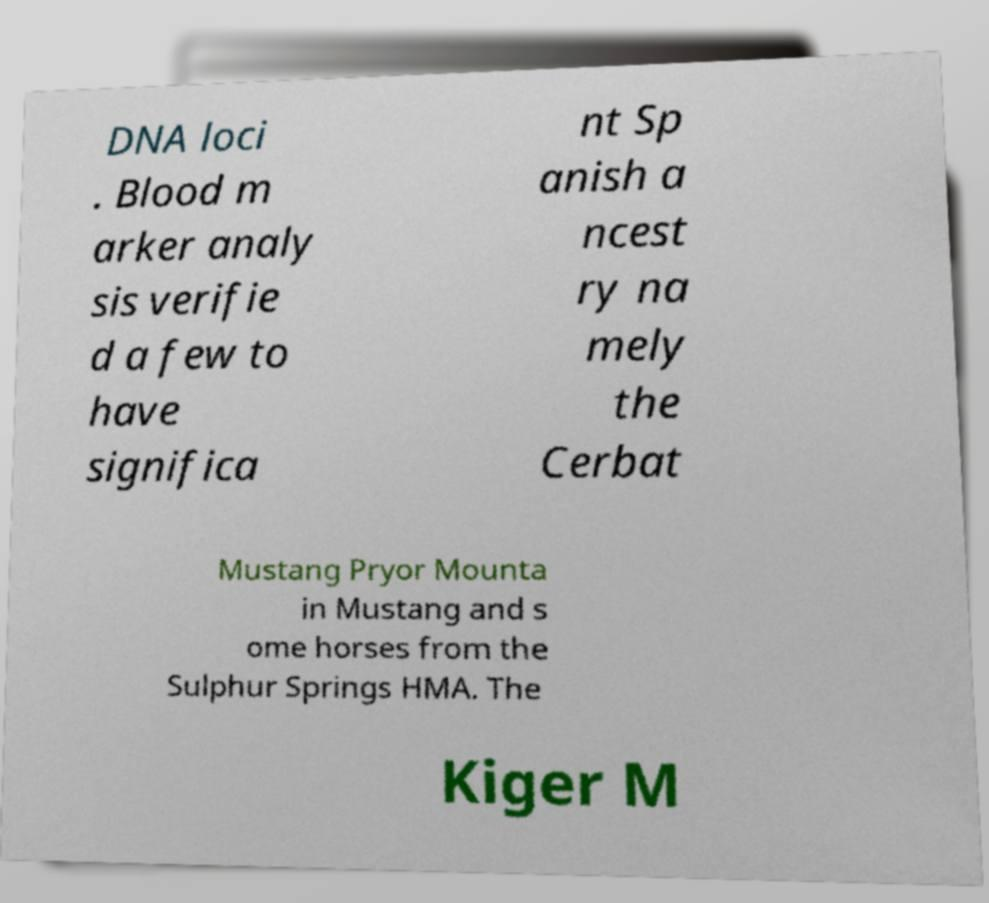Can you read and provide the text displayed in the image?This photo seems to have some interesting text. Can you extract and type it out for me? DNA loci . Blood m arker analy sis verifie d a few to have significa nt Sp anish a ncest ry na mely the Cerbat Mustang Pryor Mounta in Mustang and s ome horses from the Sulphur Springs HMA. The Kiger M 